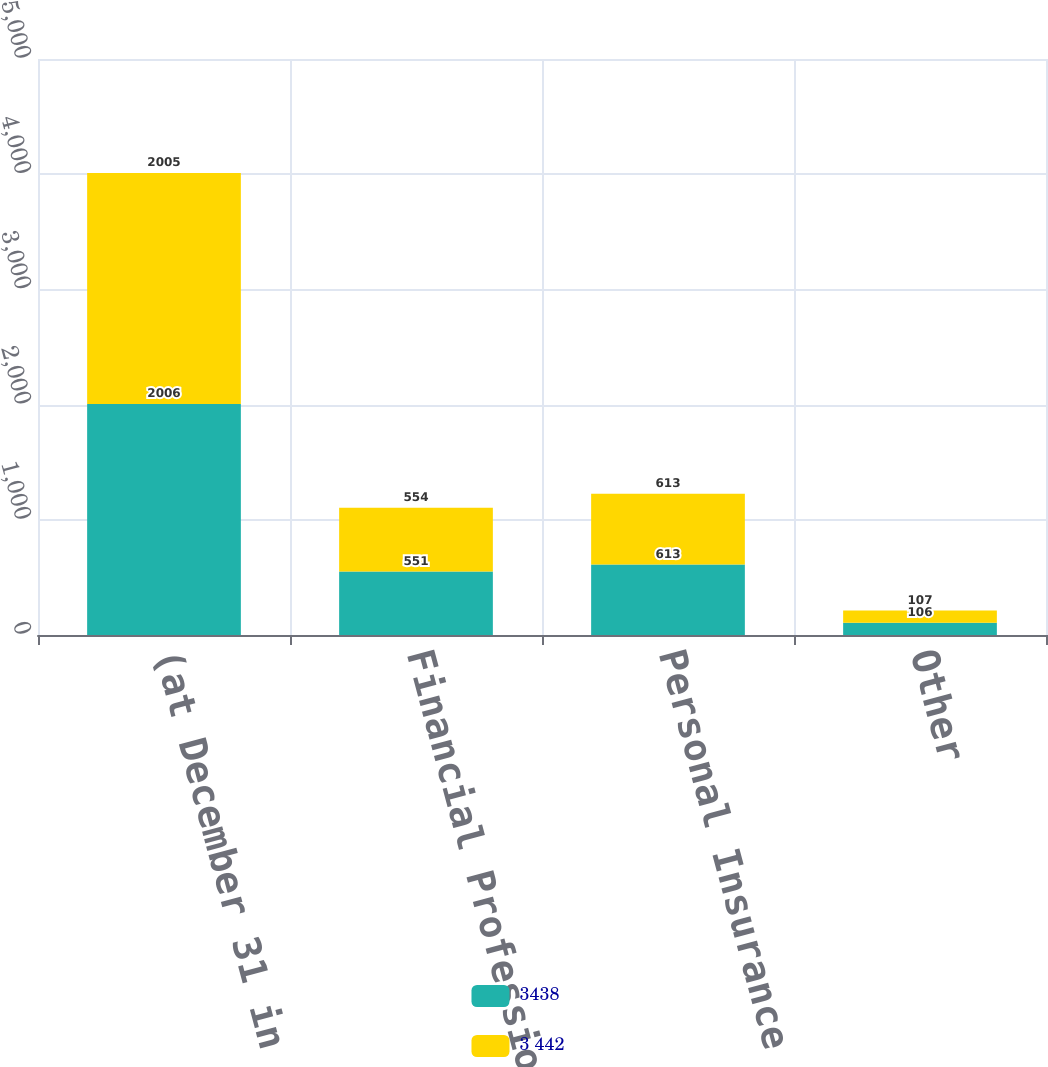Convert chart to OTSL. <chart><loc_0><loc_0><loc_500><loc_500><stacked_bar_chart><ecel><fcel>(at December 31 in millions)<fcel>Financial Professional &<fcel>Personal Insurance<fcel>Other<nl><fcel>3438<fcel>2006<fcel>551<fcel>613<fcel>106<nl><fcel>3 442<fcel>2005<fcel>554<fcel>613<fcel>107<nl></chart> 